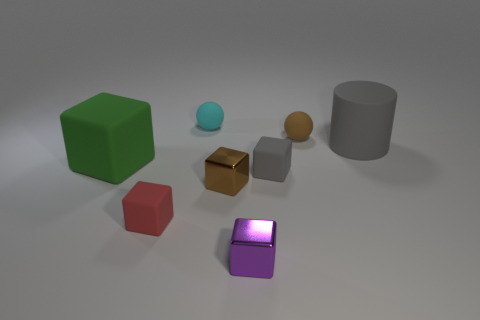What color is the matte block that is to the left of the small red matte cube to the left of the small brown thing that is in front of the gray cylinder? The matte block to the left of the small red matte cube, which in turn is situated to the left of the small brown object in front of the gray cylinder, is green in color. This block appears to be a standard square prism commonly referred to as a block or cube. 